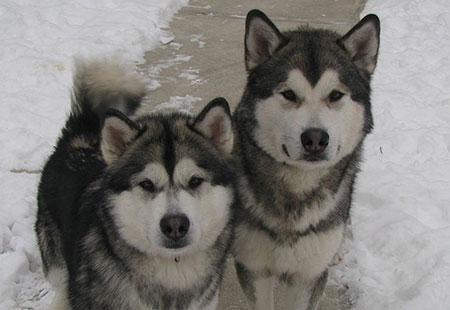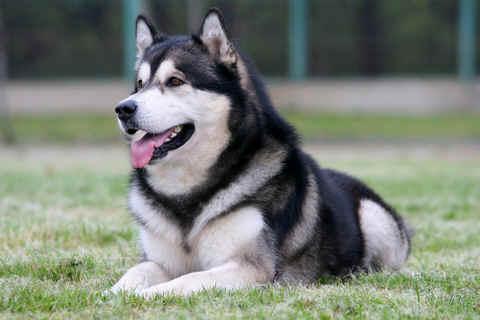The first image is the image on the left, the second image is the image on the right. Examine the images to the left and right. Is the description "There are more dogs in the image on the left." accurate? Answer yes or no. Yes. The first image is the image on the left, the second image is the image on the right. Assess this claim about the two images: "The left image includes two huskies side-by-side on snowy ground, and the right image includes one woman with at least one husky.". Correct or not? Answer yes or no. No. 